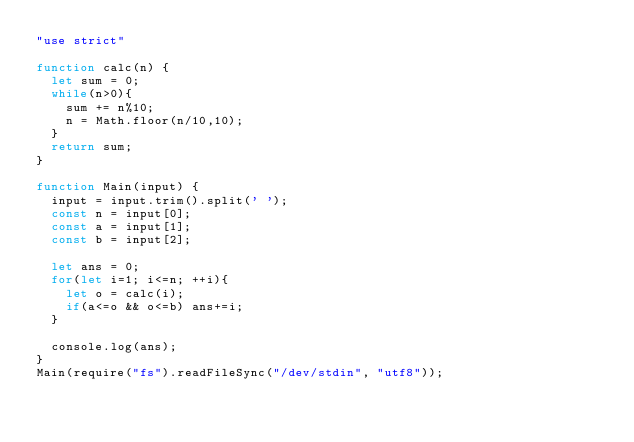Convert code to text. <code><loc_0><loc_0><loc_500><loc_500><_JavaScript_>"use strict"

function calc(n) {
  let sum = 0;
  while(n>0){
    sum += n%10;
    n = Math.floor(n/10,10);
  }
  return sum;
}

function Main(input) {
  input = input.trim().split(' ');
  const n = input[0];
  const a = input[1];
  const b = input[2];

  let ans = 0;
  for(let i=1; i<=n; ++i){
    let o = calc(i);
    if(a<=o && o<=b) ans+=i;
  }

  console.log(ans);
}
Main(require("fs").readFileSync("/dev/stdin", "utf8"));</code> 